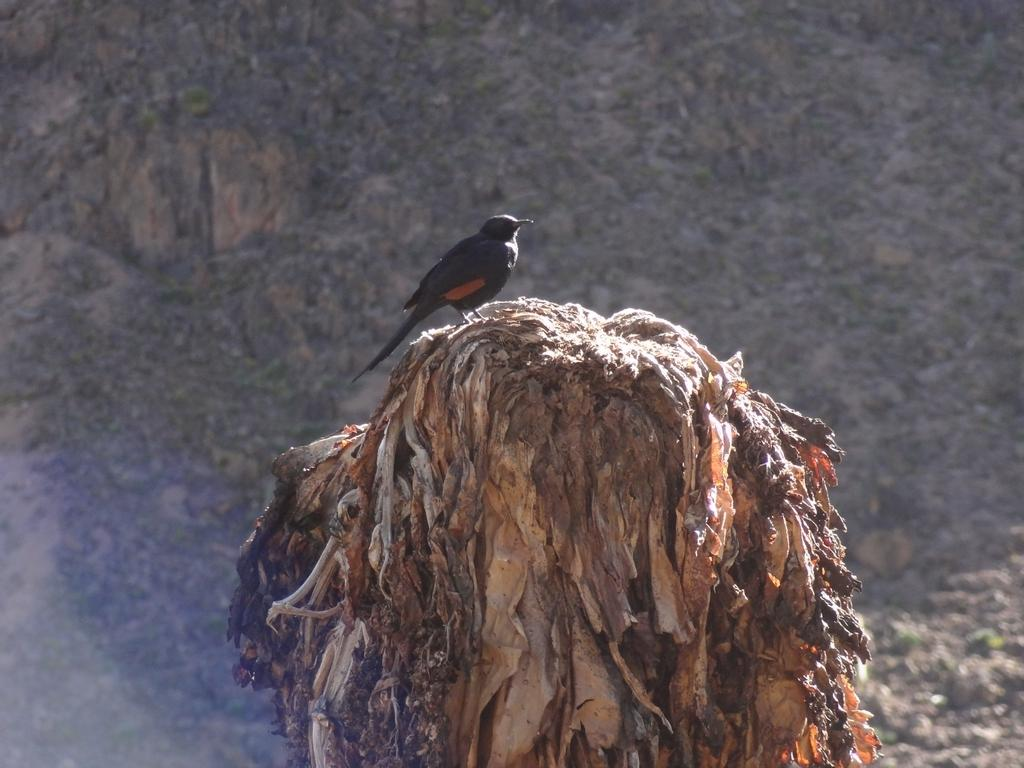What type of animal is in the image? There is a bird in the image. Where is the bird located? The bird is on the bark of a tree. What type of sweater is the bird wearing in the image? There is no sweater present in the image; the bird is on the bark of a tree. 